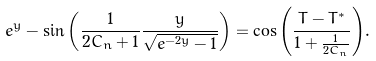Convert formula to latex. <formula><loc_0><loc_0><loc_500><loc_500>e ^ { y } - \sin { \left ( \frac { 1 } { 2 C _ { n } + 1 } \frac { y } { \sqrt { e ^ { - 2 y } - 1 } } \right ) } = \cos { \left ( \frac { T - T ^ { * } } { 1 + \frac { 1 } { 2 C _ { n } } } \right ) } .</formula> 